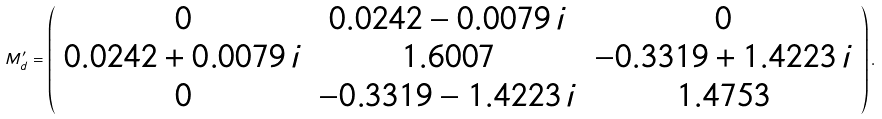Convert formula to latex. <formula><loc_0><loc_0><loc_500><loc_500>M _ { d } ^ { \prime } = \left ( \begin{array} { c c c } { 0 } & { 0 . 0 2 4 2 - 0 . 0 0 7 9 \, i } & { 0 } \\ { 0 . 0 2 4 2 + 0 . 0 0 7 9 \, i } & { 1 . 6 0 0 7 } & { - 0 . 3 3 1 9 + 1 . 4 2 2 3 \, i } \\ { 0 } & { - 0 . 3 3 1 9 - 1 . 4 2 2 3 \, i } & { 1 . 4 7 5 3 } \end{array} \right ) .</formula> 